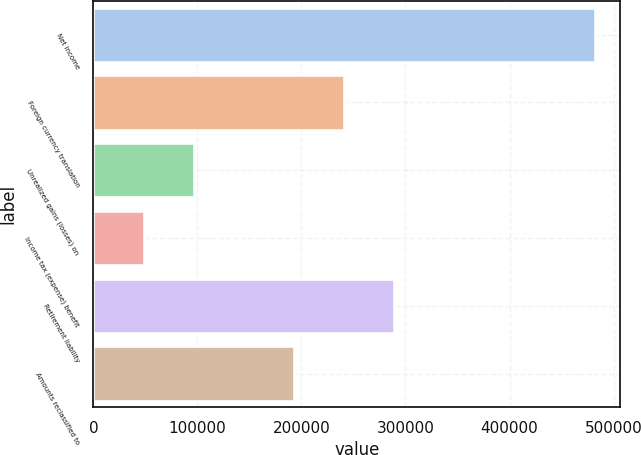<chart> <loc_0><loc_0><loc_500><loc_500><bar_chart><fcel>Net income<fcel>Foreign currency translation<fcel>Unrealized gains (losses) on<fcel>Income tax (expense) benefit<fcel>Retirement liability<fcel>Amounts reclassified to<nl><fcel>482277<fcel>241206<fcel>96562.6<fcel>48348.3<fcel>289420<fcel>192991<nl></chart> 